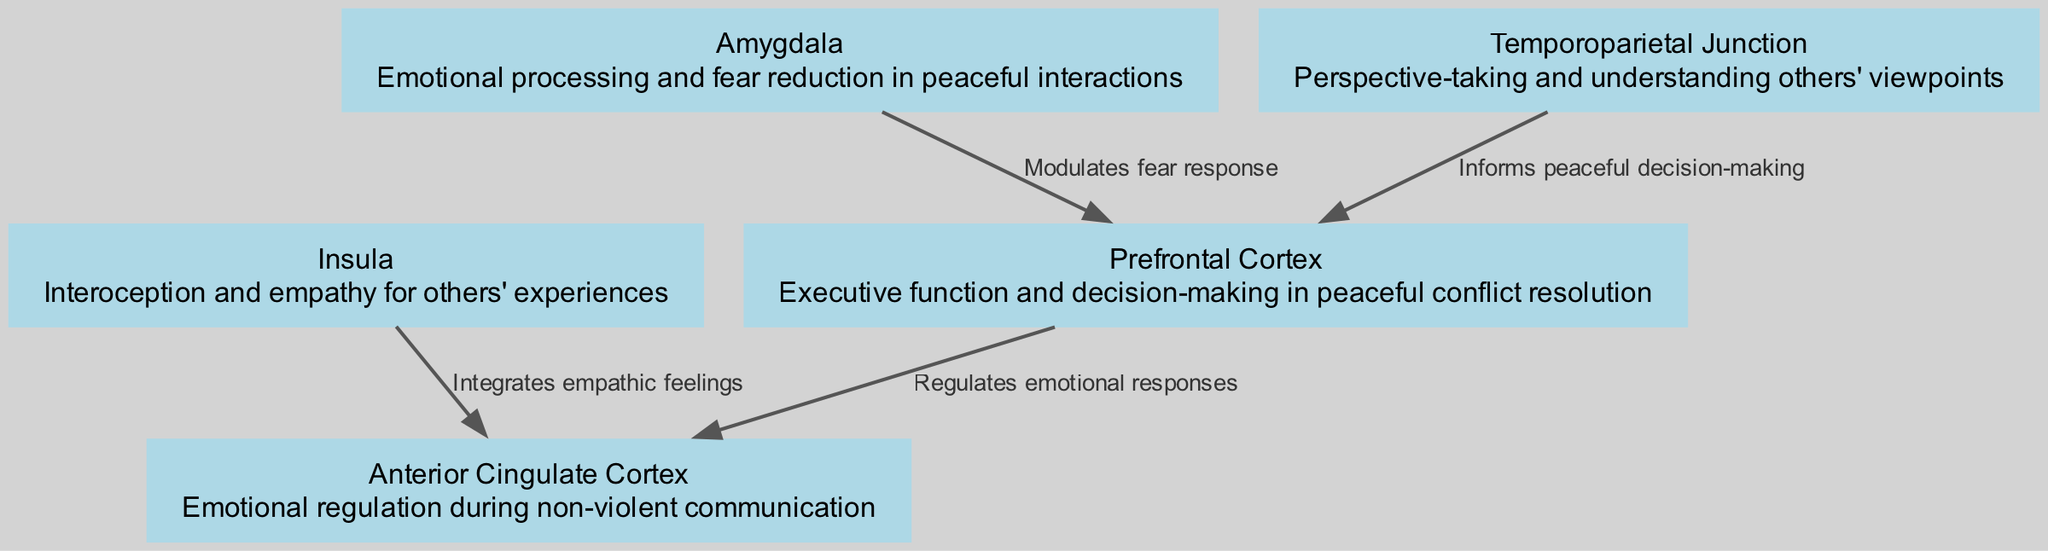What is the first node in the diagram? The diagram starts with the node labeled "Prefrontal Cortex." This is determined by looking at the arrangement of the nodes, as the first node appears at the top of the graph.
Answer: Prefrontal Cortex How many nodes are in the diagram? By counting all the listed nodes in the data, there are five nodes present in the neurological pathways diagram: Prefrontal Cortex, Anterior Cingulate Cortex, Insula, Amygdala, and Temporoparietal Junction.
Answer: 5 What does the Anterior Cingulate Cortex regulate? The label on the Anterior Cingulate Cortex in the diagram describes it as responsible for "Emotional regulation during non-violent communication." This is explicitly stated in the description of that node.
Answer: Emotional regulation during non-violent communication Which node connects to the Prefrontal Cortex and is involved in perspective-taking? The Temporoparietal Junction connects to the Prefrontal Cortex, and it is specified in the diagram as responsible for "Perspective-taking and understanding others' viewpoints." This shows its role in understanding perspectives leading to peaceful thoughts.
Answer: Temporoparietal Junction How does the Insula affect the Anterior Cingulate Cortex? The diagram indicates that the Insula "Integrates empathic feelings," and it connects directly to the Anterior Cingulate Cortex, suggesting that these empathic feelings play a role in emotional regulation managed by the Anterior Cingulate Cortex.
Answer: Integrates empathic feelings What is the function of the Amygdala in peaceful interactions? According to the description provided for the Amygdala in the diagram, its purpose is labeled as "Emotional processing and fear reduction in peaceful interactions," indicating its role in facilitating peaceful state of mind.
Answer: Emotional processing and fear reduction in peaceful interactions Which node informs peaceful decision-making? The Temporoparietal Junction is indicated to inform peaceful decision-making by connecting to the Prefrontal Cortex and providing perspective-taking abilities, helping to navigate emotional choices towards peace.
Answer: Temporoparietal Junction What type of edge connects the Prefrontal Cortex and the Anterior Cingulate Cortex? The edge labeled "Regulates emotional responses" is the specific connection between the Prefrontal Cortex and the Anterior Cingulate Cortex, indicating the nature of their interaction as focusing on regulation.
Answer: Regulates emotional responses 